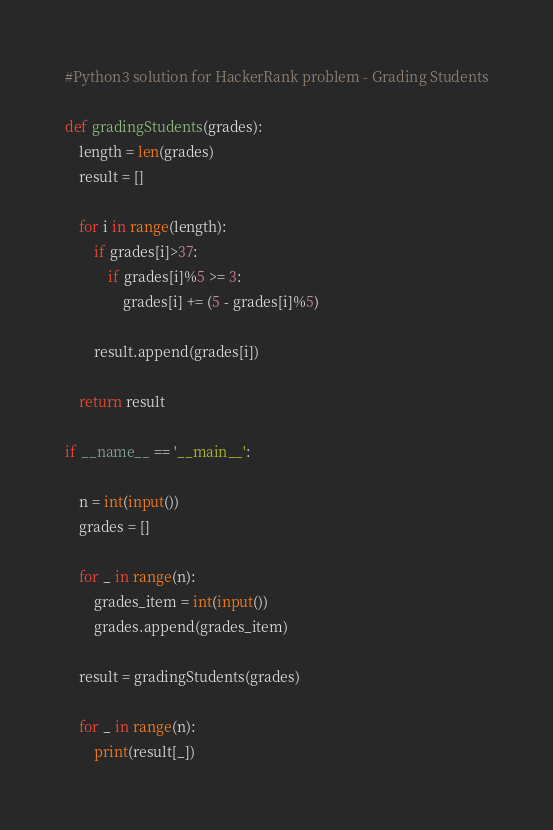Convert code to text. <code><loc_0><loc_0><loc_500><loc_500><_Python_>#Python3 solution for HackerRank problem - Grading Students

def gradingStudents(grades):   
    length = len(grades)
    result = []
    
    for i in range(length):
        if grades[i]>37:
            if grades[i]%5 >= 3:
                grades[i] += (5 - grades[i]%5)
                
        result.append(grades[i])
    
    return result

if __name__ == '__main__':
    
    n = int(input())   
    grades = []

    for _ in range(n):
        grades_item = int(input())
        grades.append(grades_item)

    result = gradingStudents(grades)

    for _ in range(n):
        print(result[_])</code> 